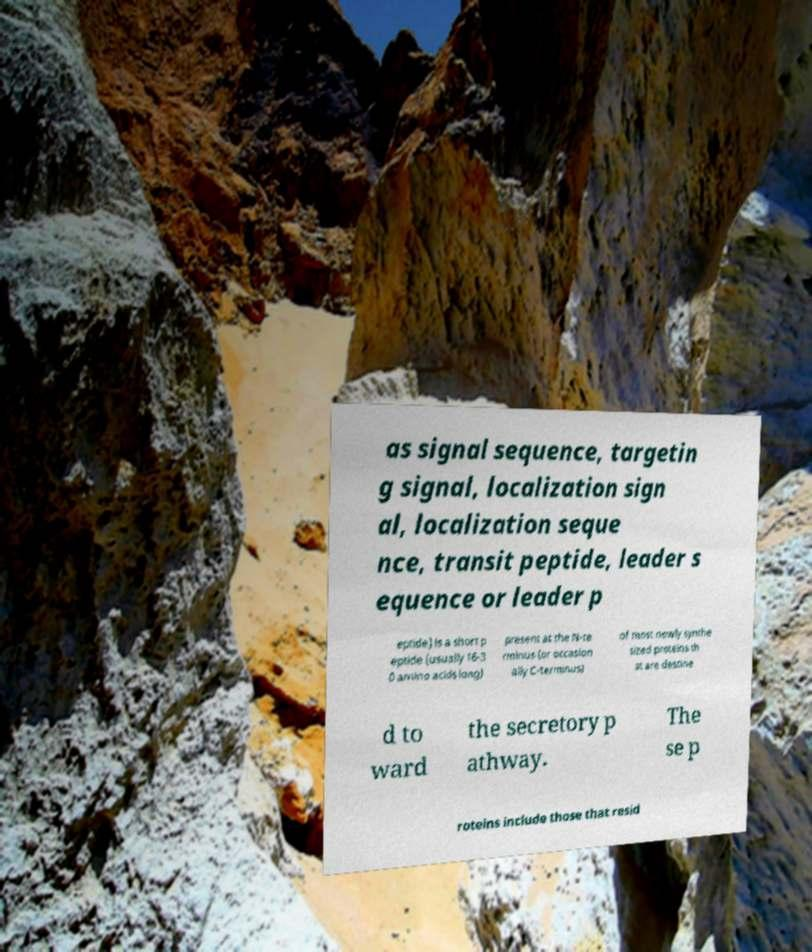What messages or text are displayed in this image? I need them in a readable, typed format. as signal sequence, targetin g signal, localization sign al, localization seque nce, transit peptide, leader s equence or leader p eptide) is a short p eptide (usually 16-3 0 amino acids long) present at the N-te rminus (or occasion ally C-terminus) of most newly synthe sized proteins th at are destine d to ward the secretory p athway. The se p roteins include those that resid 